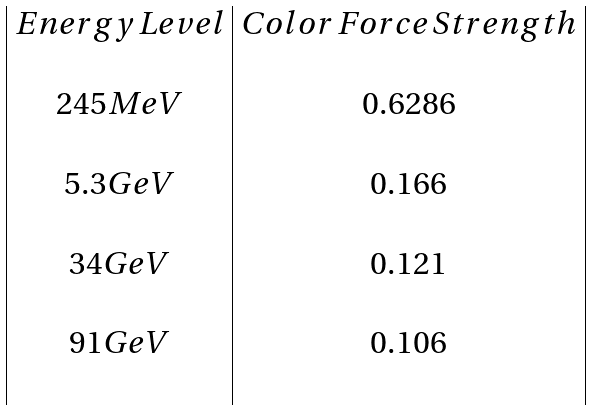Convert formula to latex. <formula><loc_0><loc_0><loc_500><loc_500>\begin{array} { | c | c | } E n e r g y \, L e v e l & C o l o r \, F o r c e \, S t r e n g t h \\ & \\ 2 4 5 M e V & 0 . 6 2 8 6 \\ & \\ 5 . 3 G e V & 0 . 1 6 6 \\ & \\ 3 4 G e V & 0 . 1 2 1 \\ & \\ 9 1 G e V & 0 . 1 0 6 \\ & \\ \end{array}</formula> 